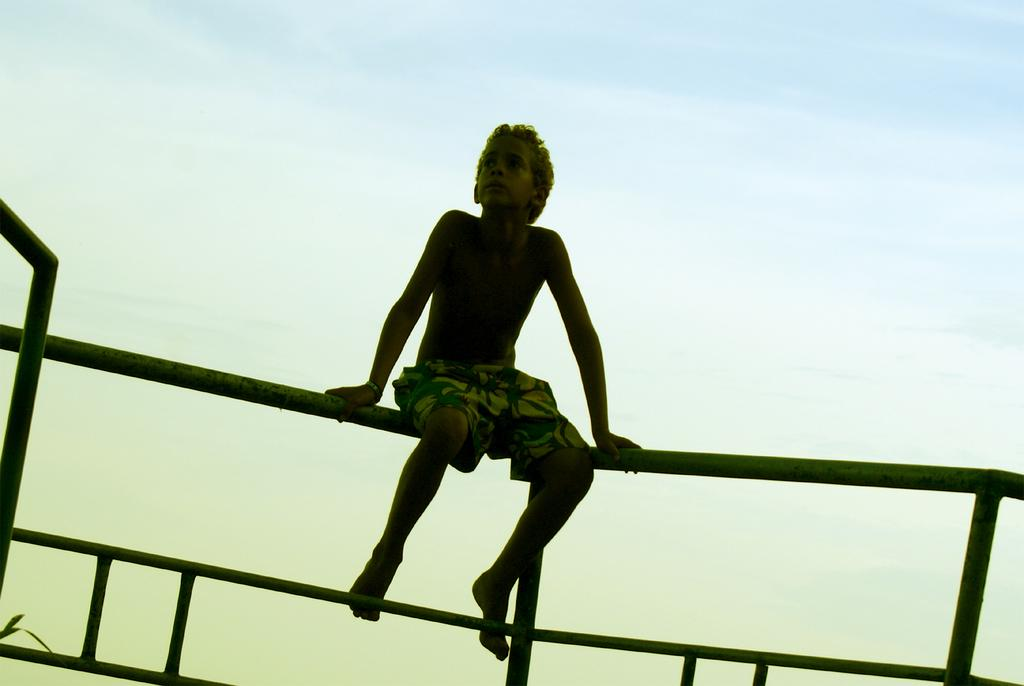Who is the main subject in the image? There is a boy in the image. What is the boy wearing? The boy is wearing shorts. What is the boy doing in the image? The boy is sitting on a metal railing. What can be seen in the background of the image? There is a sky visible in the background of the image. What type of reaction does the duck have to the boy sitting on the railing in the image? There is no duck present in the image, so it is not possible to determine any reaction. 